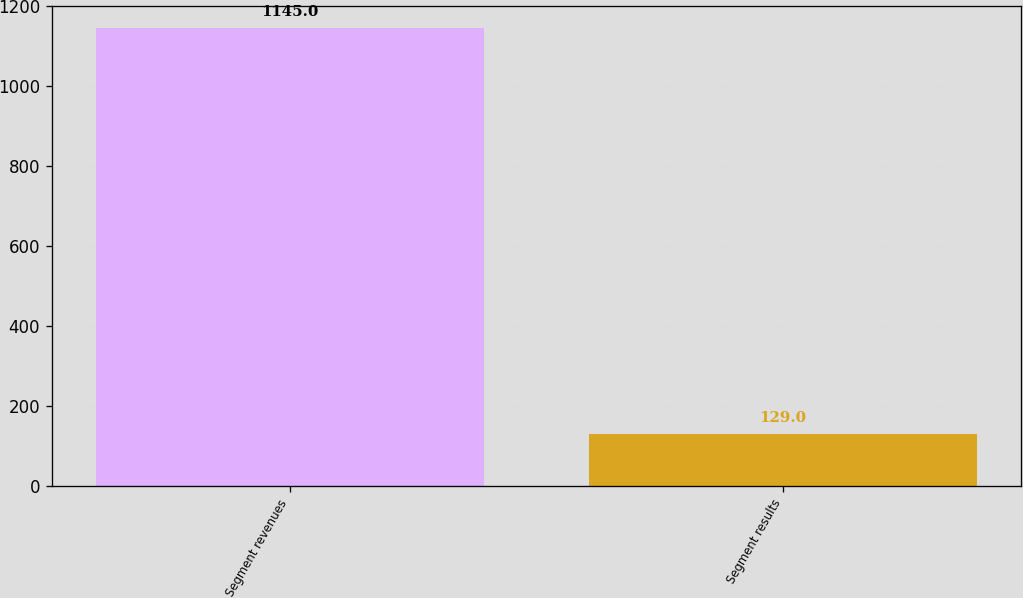<chart> <loc_0><loc_0><loc_500><loc_500><bar_chart><fcel>Segment revenues<fcel>Segment results<nl><fcel>1145<fcel>129<nl></chart> 